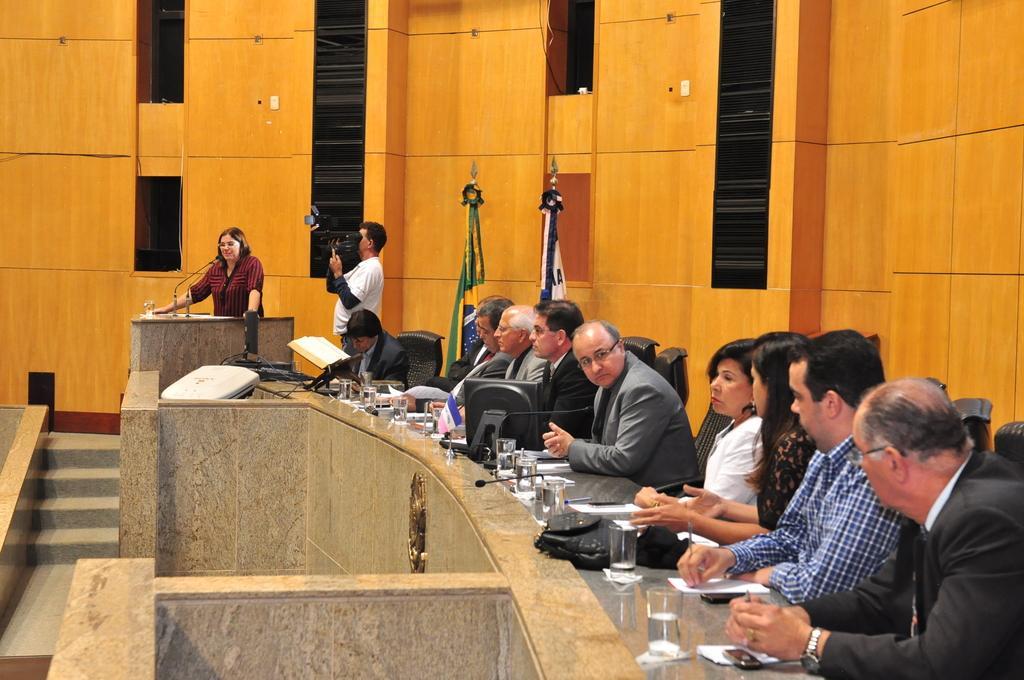Can you describe this image briefly? In this picture I can see see number of people on right, who are sitting on chairs and I see the grey surface in front of them, on which there are glasses, a monitor and other things. On the left side of this image I can see the steps and I can see a podium on which there are 2 mics and behind it I can see a woman and side to her I can see a man holding a camera. In the background I can see the wall, on which there are black color things and I see flags. In the front of this picture I can see the marble wall. 